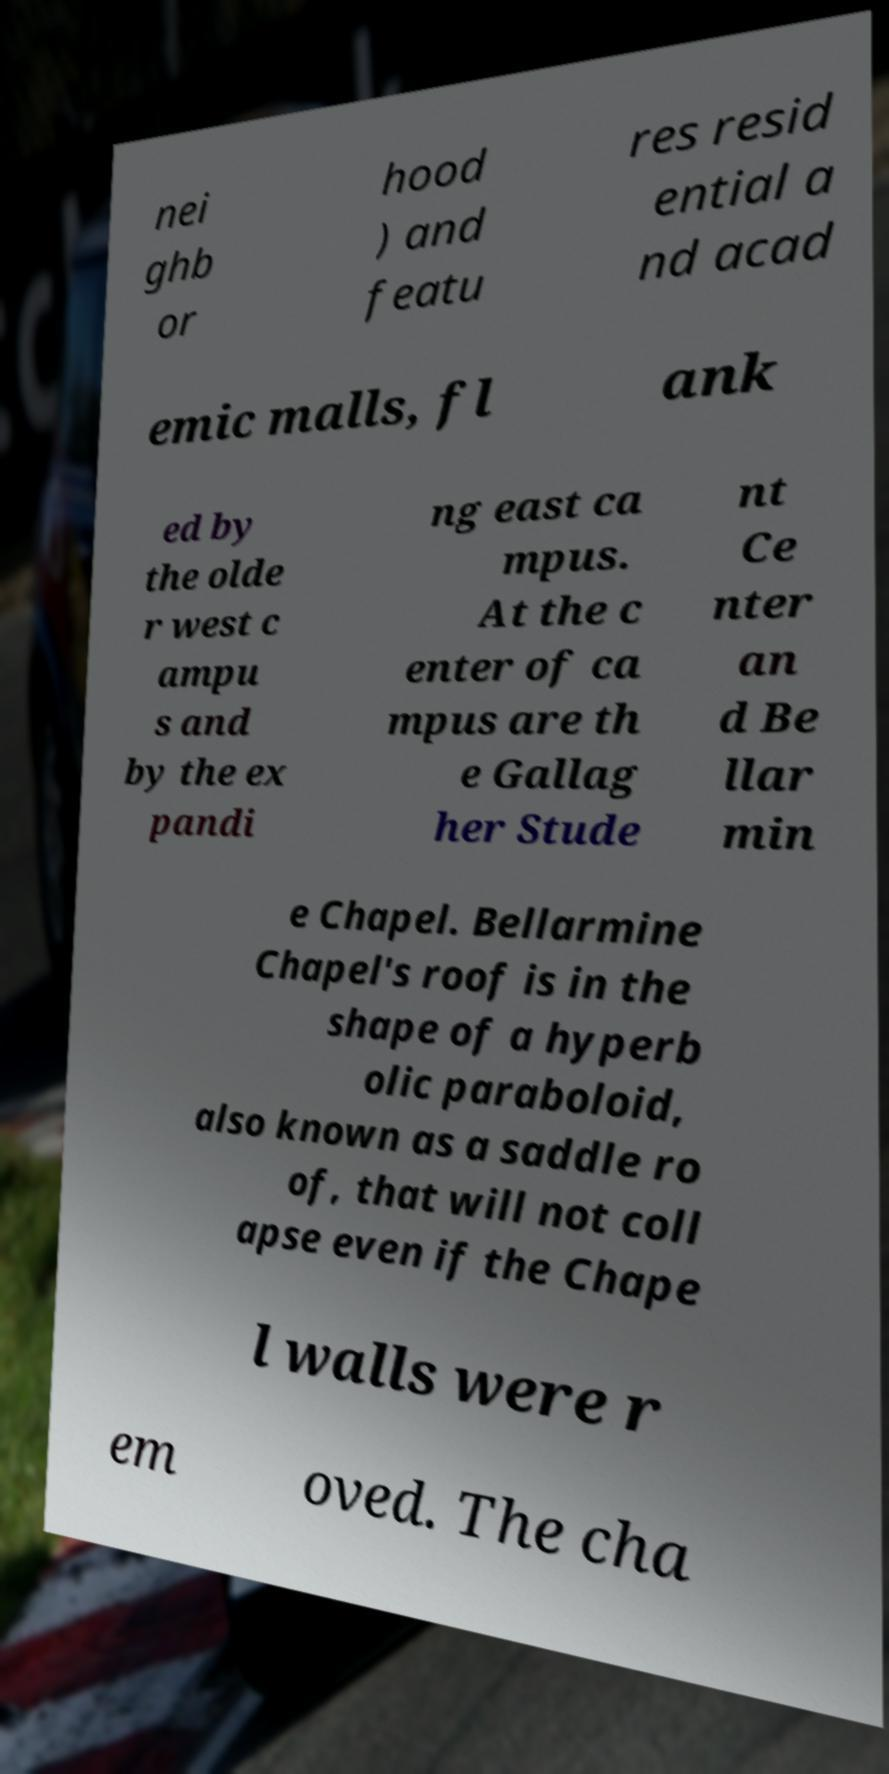For documentation purposes, I need the text within this image transcribed. Could you provide that? nei ghb or hood ) and featu res resid ential a nd acad emic malls, fl ank ed by the olde r west c ampu s and by the ex pandi ng east ca mpus. At the c enter of ca mpus are th e Gallag her Stude nt Ce nter an d Be llar min e Chapel. Bellarmine Chapel's roof is in the shape of a hyperb olic paraboloid, also known as a saddle ro of, that will not coll apse even if the Chape l walls were r em oved. The cha 